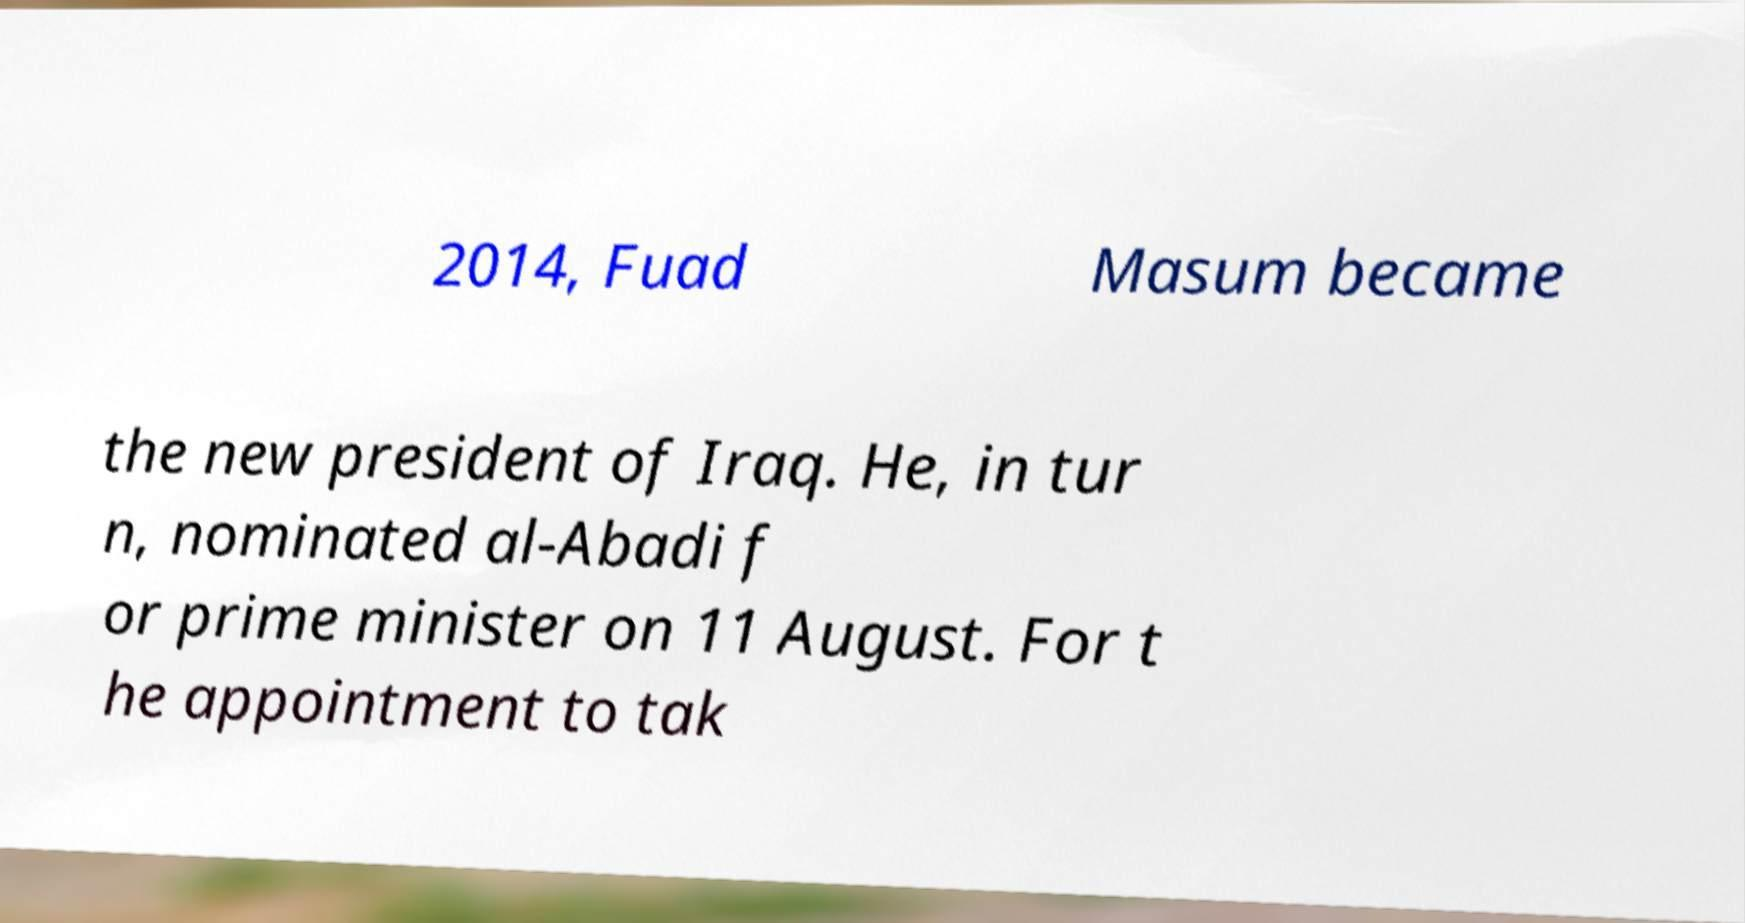What messages or text are displayed in this image? I need them in a readable, typed format. 2014, Fuad Masum became the new president of Iraq. He, in tur n, nominated al-Abadi f or prime minister on 11 August. For t he appointment to tak 